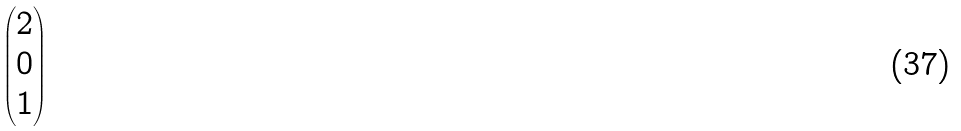<formula> <loc_0><loc_0><loc_500><loc_500>\begin{pmatrix} 2 \\ 0 \\ 1 \end{pmatrix}</formula> 